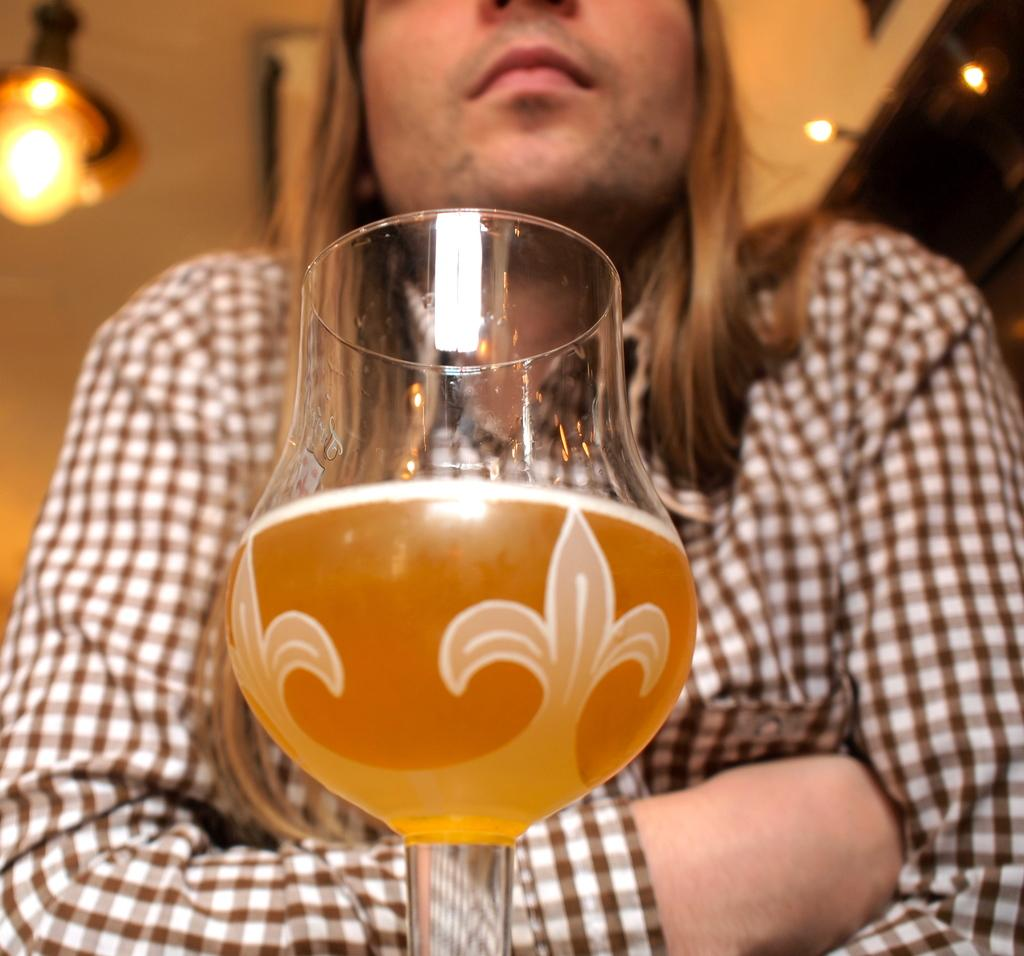What is present in the image? There is a person and a glass in the image. What is in the glass? There is liquid in the glass. What color is the orange shirt the person is wearing in the image? There is no orange shirt present in the image. 